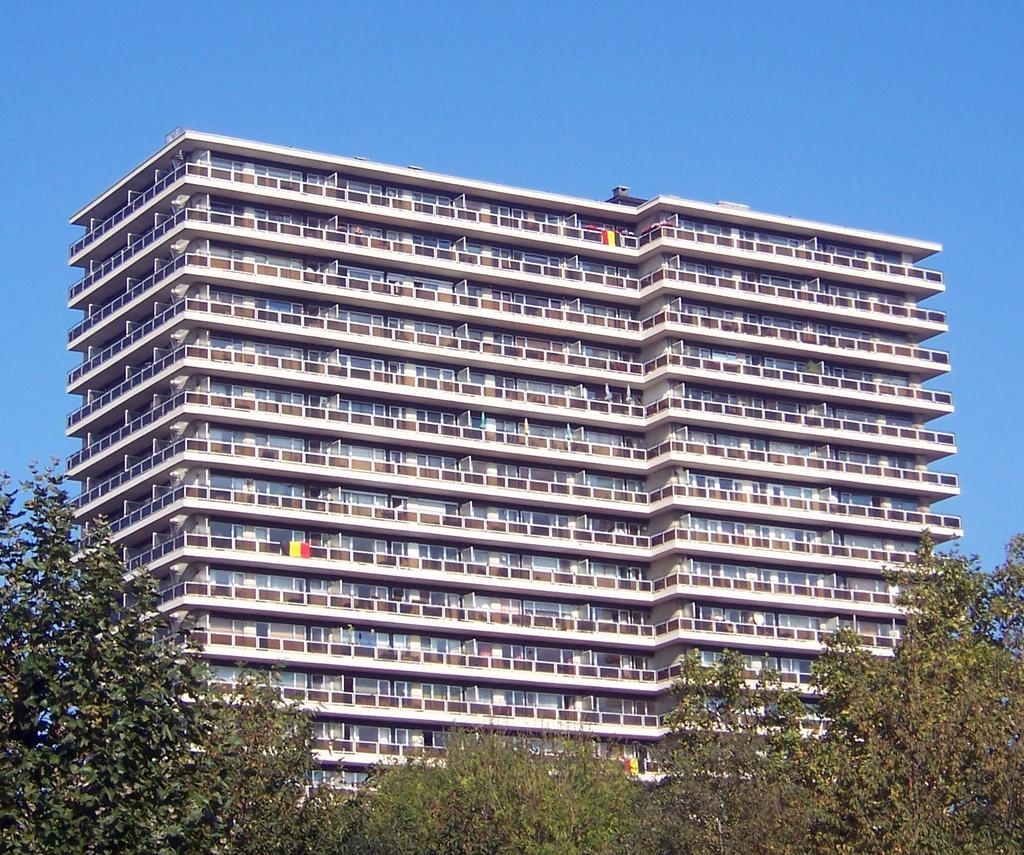Could you give a brief overview of what you see in this image? In this image, we can see a building. Here we can see walls, windows and railings. Background there is a sky. At the bottom of the image, we can see trees. 